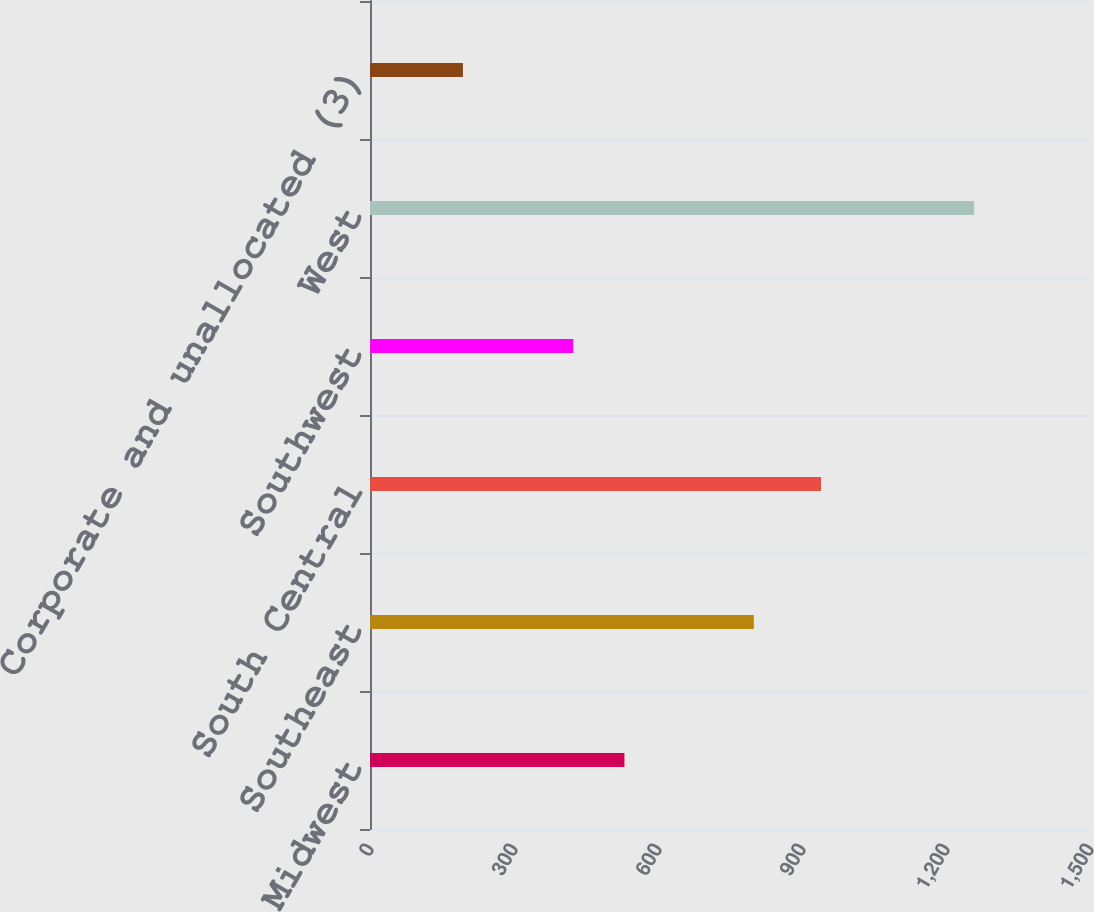Convert chart to OTSL. <chart><loc_0><loc_0><loc_500><loc_500><bar_chart><fcel>Midwest<fcel>Southeast<fcel>South Central<fcel>Southwest<fcel>West<fcel>Corporate and unallocated (3)<nl><fcel>530.08<fcel>799.6<fcel>939.7<fcel>423.6<fcel>1258.4<fcel>193.6<nl></chart> 